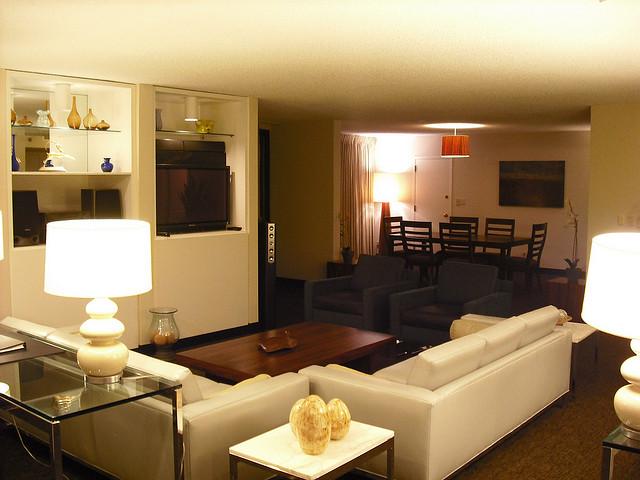What color are the walls?
Keep it brief. White. What type of surface are the closest lamps on?
Give a very brief answer. Glass. Are the light on or off?
Quick response, please. On. 